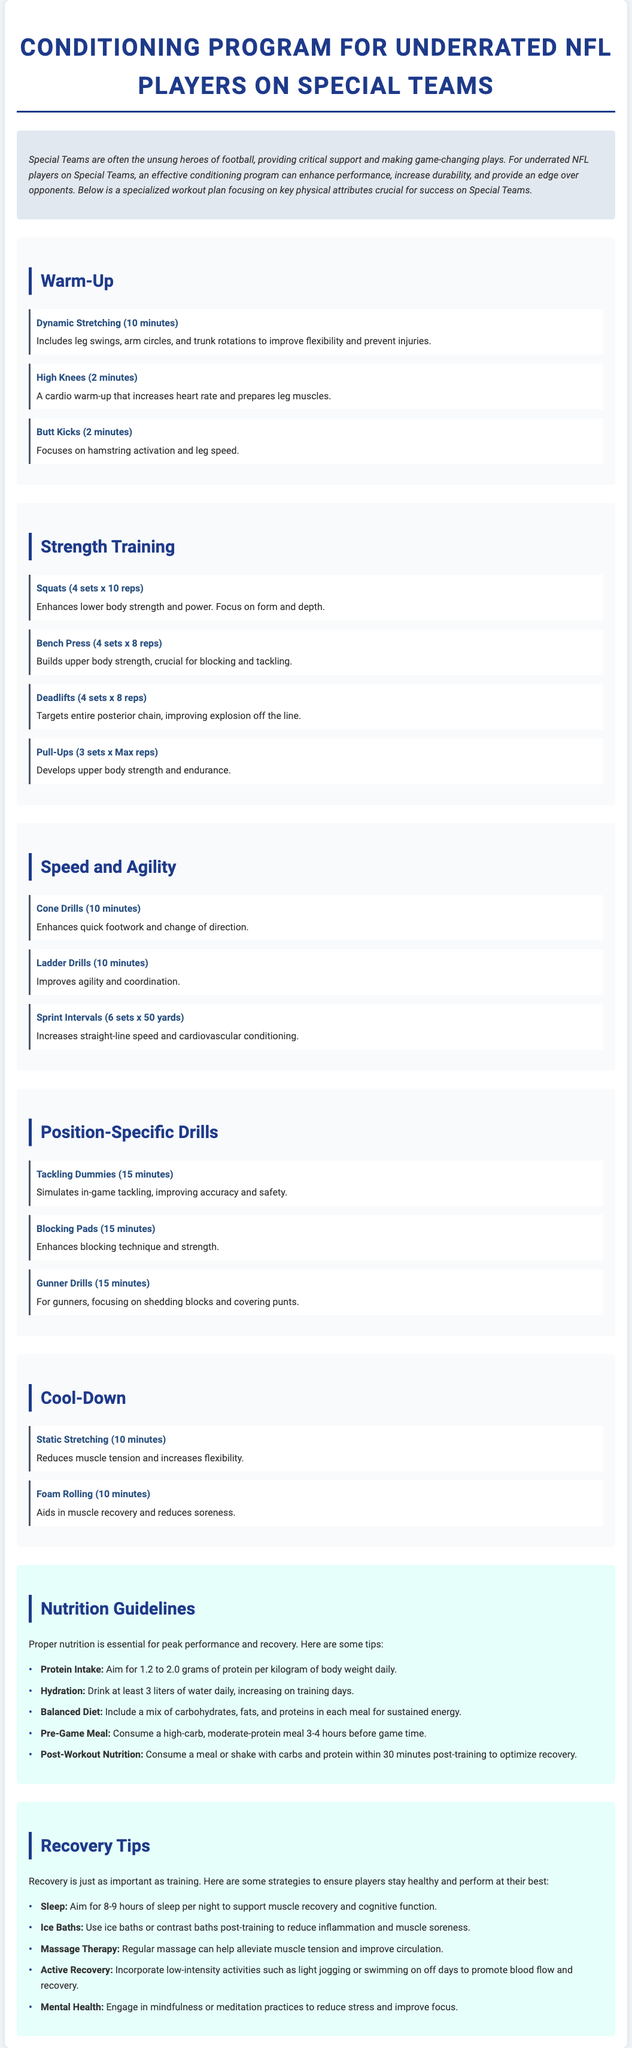What is the title of the document? The title of the document is prominently displayed at the top of the page, stating the focus of the program.
Answer: Conditioning Program for Underrated NFL Players on Special Teams How many minutes are allocated for dynamic stretching? The document specifies the duration allocated for each activity within the warm-up section, including dynamic stretching.
Answer: 10 minutes How many sets and reps are suggested for squats? The workout plan details the structure of the strength training exercises, specifically mentioning the sets and reps for squats.
Answer: 4 sets x 10 reps What should players consume within 30 minutes post-training? The nutrition guidelines section emphasizes the importance of post-workout nutrition, specifying what to consume after training.
Answer: A meal or shake with carbs and protein What is one recovery strategy mentioned for muscle soreness? The recovery tips provide several methods for managing muscle soreness after training, highlighting specific techniques.
Answer: Ice Baths How long is the total time recommended for the cooldown section? The sum of the duration of both activities within the cooldown section gives the total time recommended.
Answer: 20 minutes What is emphasized as essential for peak performance? The nutrition guidelines outline essential practices for athletes to perform optimally.
Answer: Proper nutrition How many minutes is allocated for tackling dummies in position-specific drills? The time given for each activity in the position-specific drills section indicates how long players should practice tackling dummies.
Answer: 15 minutes What fluid intake is recommended daily? The nutrition section explicitly indicates the amount of hydration necessary for proper performance.
Answer: At least 3 liters 